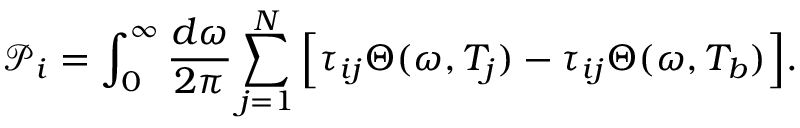Convert formula to latex. <formula><loc_0><loc_0><loc_500><loc_500>\mathcal { P } _ { i } = \int _ { 0 } ^ { \infty } \frac { d \omega } { 2 \pi } \sum _ { j = 1 } ^ { N } \left [ \tau _ { i j } \Theta ( \omega , T _ { j } ) - \tau _ { i j } \Theta ( \omega , T _ { b } ) \right ] .</formula> 